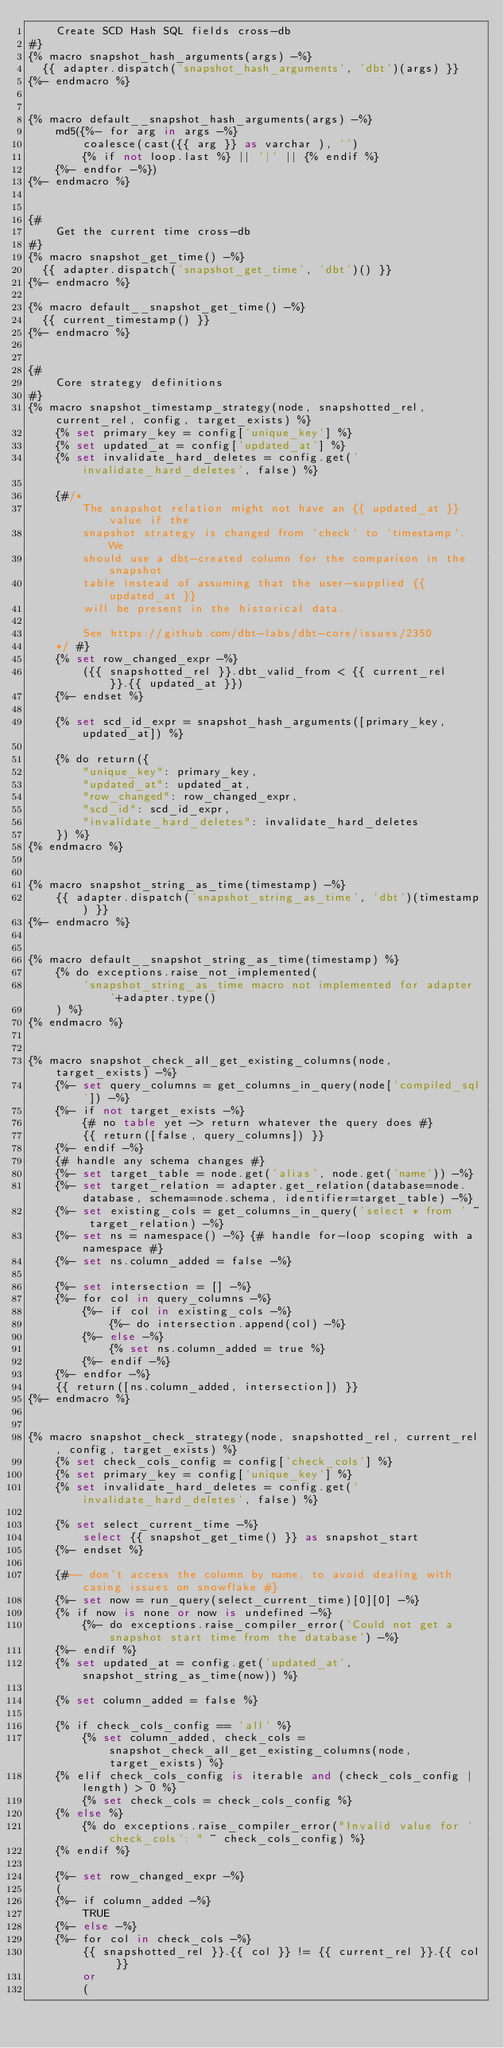Convert code to text. <code><loc_0><loc_0><loc_500><loc_500><_SQL_>    Create SCD Hash SQL fields cross-db
#}
{% macro snapshot_hash_arguments(args) -%}
  {{ adapter.dispatch('snapshot_hash_arguments', 'dbt')(args) }}
{%- endmacro %}


{% macro default__snapshot_hash_arguments(args) -%}
    md5({%- for arg in args -%}
        coalesce(cast({{ arg }} as varchar ), '')
        {% if not loop.last %} || '|' || {% endif %}
    {%- endfor -%})
{%- endmacro %}


{#
    Get the current time cross-db
#}
{% macro snapshot_get_time() -%}
  {{ adapter.dispatch('snapshot_get_time', 'dbt')() }}
{%- endmacro %}

{% macro default__snapshot_get_time() -%}
  {{ current_timestamp() }}
{%- endmacro %}


{#
    Core strategy definitions
#}
{% macro snapshot_timestamp_strategy(node, snapshotted_rel, current_rel, config, target_exists) %}
    {% set primary_key = config['unique_key'] %}
    {% set updated_at = config['updated_at'] %}
    {% set invalidate_hard_deletes = config.get('invalidate_hard_deletes', false) %}

    {#/*
        The snapshot relation might not have an {{ updated_at }} value if the
        snapshot strategy is changed from `check` to `timestamp`. We
        should use a dbt-created column for the comparison in the snapshot
        table instead of assuming that the user-supplied {{ updated_at }}
        will be present in the historical data.

        See https://github.com/dbt-labs/dbt-core/issues/2350
    */ #}
    {% set row_changed_expr -%}
        ({{ snapshotted_rel }}.dbt_valid_from < {{ current_rel }}.{{ updated_at }})
    {%- endset %}

    {% set scd_id_expr = snapshot_hash_arguments([primary_key, updated_at]) %}

    {% do return({
        "unique_key": primary_key,
        "updated_at": updated_at,
        "row_changed": row_changed_expr,
        "scd_id": scd_id_expr,
        "invalidate_hard_deletes": invalidate_hard_deletes
    }) %}
{% endmacro %}


{% macro snapshot_string_as_time(timestamp) -%}
    {{ adapter.dispatch('snapshot_string_as_time', 'dbt')(timestamp) }}
{%- endmacro %}


{% macro default__snapshot_string_as_time(timestamp) %}
    {% do exceptions.raise_not_implemented(
        'snapshot_string_as_time macro not implemented for adapter '+adapter.type()
    ) %}
{% endmacro %}


{% macro snapshot_check_all_get_existing_columns(node, target_exists) -%}
    {%- set query_columns = get_columns_in_query(node['compiled_sql']) -%}
    {%- if not target_exists -%}
        {# no table yet -> return whatever the query does #}
        {{ return([false, query_columns]) }}
    {%- endif -%}
    {# handle any schema changes #}
    {%- set target_table = node.get('alias', node.get('name')) -%}
    {%- set target_relation = adapter.get_relation(database=node.database, schema=node.schema, identifier=target_table) -%}
    {%- set existing_cols = get_columns_in_query('select * from ' ~ target_relation) -%}
    {%- set ns = namespace() -%} {# handle for-loop scoping with a namespace #}
    {%- set ns.column_added = false -%}

    {%- set intersection = [] -%}
    {%- for col in query_columns -%}
        {%- if col in existing_cols -%}
            {%- do intersection.append(col) -%}
        {%- else -%}
            {% set ns.column_added = true %}
        {%- endif -%}
    {%- endfor -%}
    {{ return([ns.column_added, intersection]) }}
{%- endmacro %}


{% macro snapshot_check_strategy(node, snapshotted_rel, current_rel, config, target_exists) %}
    {% set check_cols_config = config['check_cols'] %}
    {% set primary_key = config['unique_key'] %}
    {% set invalidate_hard_deletes = config.get('invalidate_hard_deletes', false) %}
    
    {% set select_current_time -%}
        select {{ snapshot_get_time() }} as snapshot_start
    {%- endset %}

    {#-- don't access the column by name, to avoid dealing with casing issues on snowflake #}
    {%- set now = run_query(select_current_time)[0][0] -%}
    {% if now is none or now is undefined -%}
        {%- do exceptions.raise_compiler_error('Could not get a snapshot start time from the database') -%}
    {%- endif %}
    {% set updated_at = config.get('updated_at', snapshot_string_as_time(now)) %}

    {% set column_added = false %}

    {% if check_cols_config == 'all' %}
        {% set column_added, check_cols = snapshot_check_all_get_existing_columns(node, target_exists) %}
    {% elif check_cols_config is iterable and (check_cols_config | length) > 0 %}
        {% set check_cols = check_cols_config %}
    {% else %}
        {% do exceptions.raise_compiler_error("Invalid value for 'check_cols': " ~ check_cols_config) %}
    {% endif %}

    {%- set row_changed_expr -%}
    (
    {%- if column_added -%}
        TRUE
    {%- else -%}
    {%- for col in check_cols -%}
        {{ snapshotted_rel }}.{{ col }} != {{ current_rel }}.{{ col }}
        or
        (</code> 